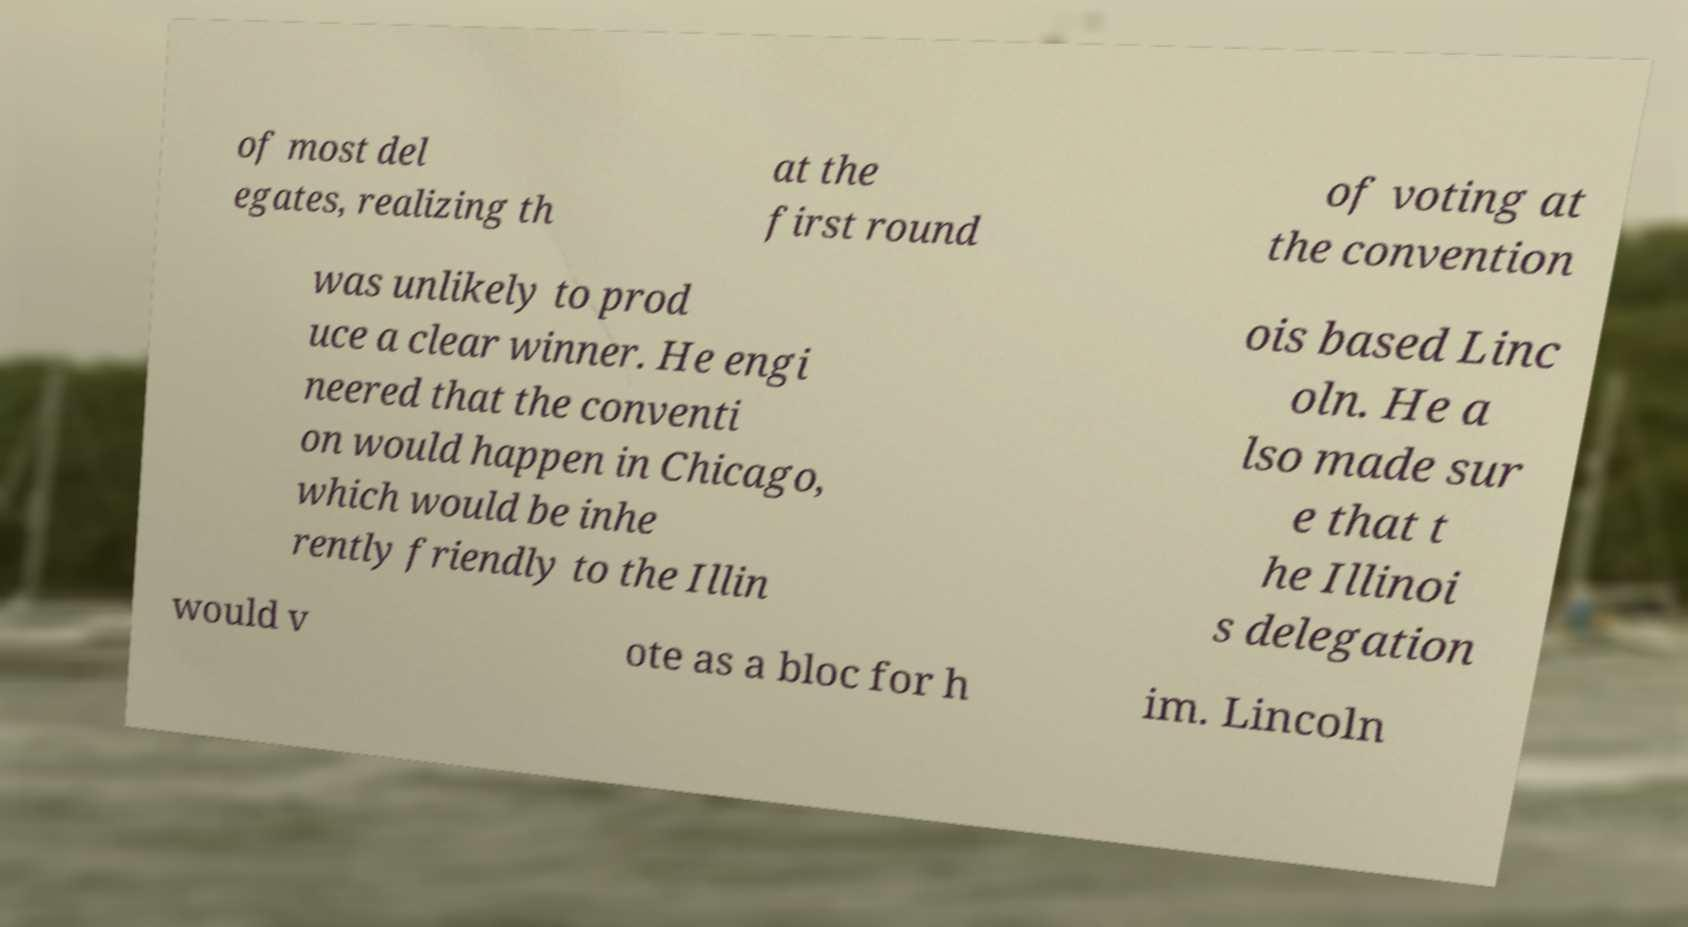Please read and relay the text visible in this image. What does it say? of most del egates, realizing th at the first round of voting at the convention was unlikely to prod uce a clear winner. He engi neered that the conventi on would happen in Chicago, which would be inhe rently friendly to the Illin ois based Linc oln. He a lso made sur e that t he Illinoi s delegation would v ote as a bloc for h im. Lincoln 